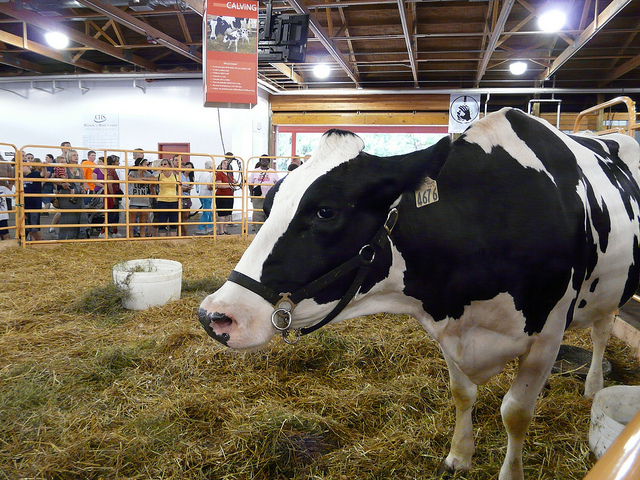Please identify all text content in this image. 4676 CALVING 